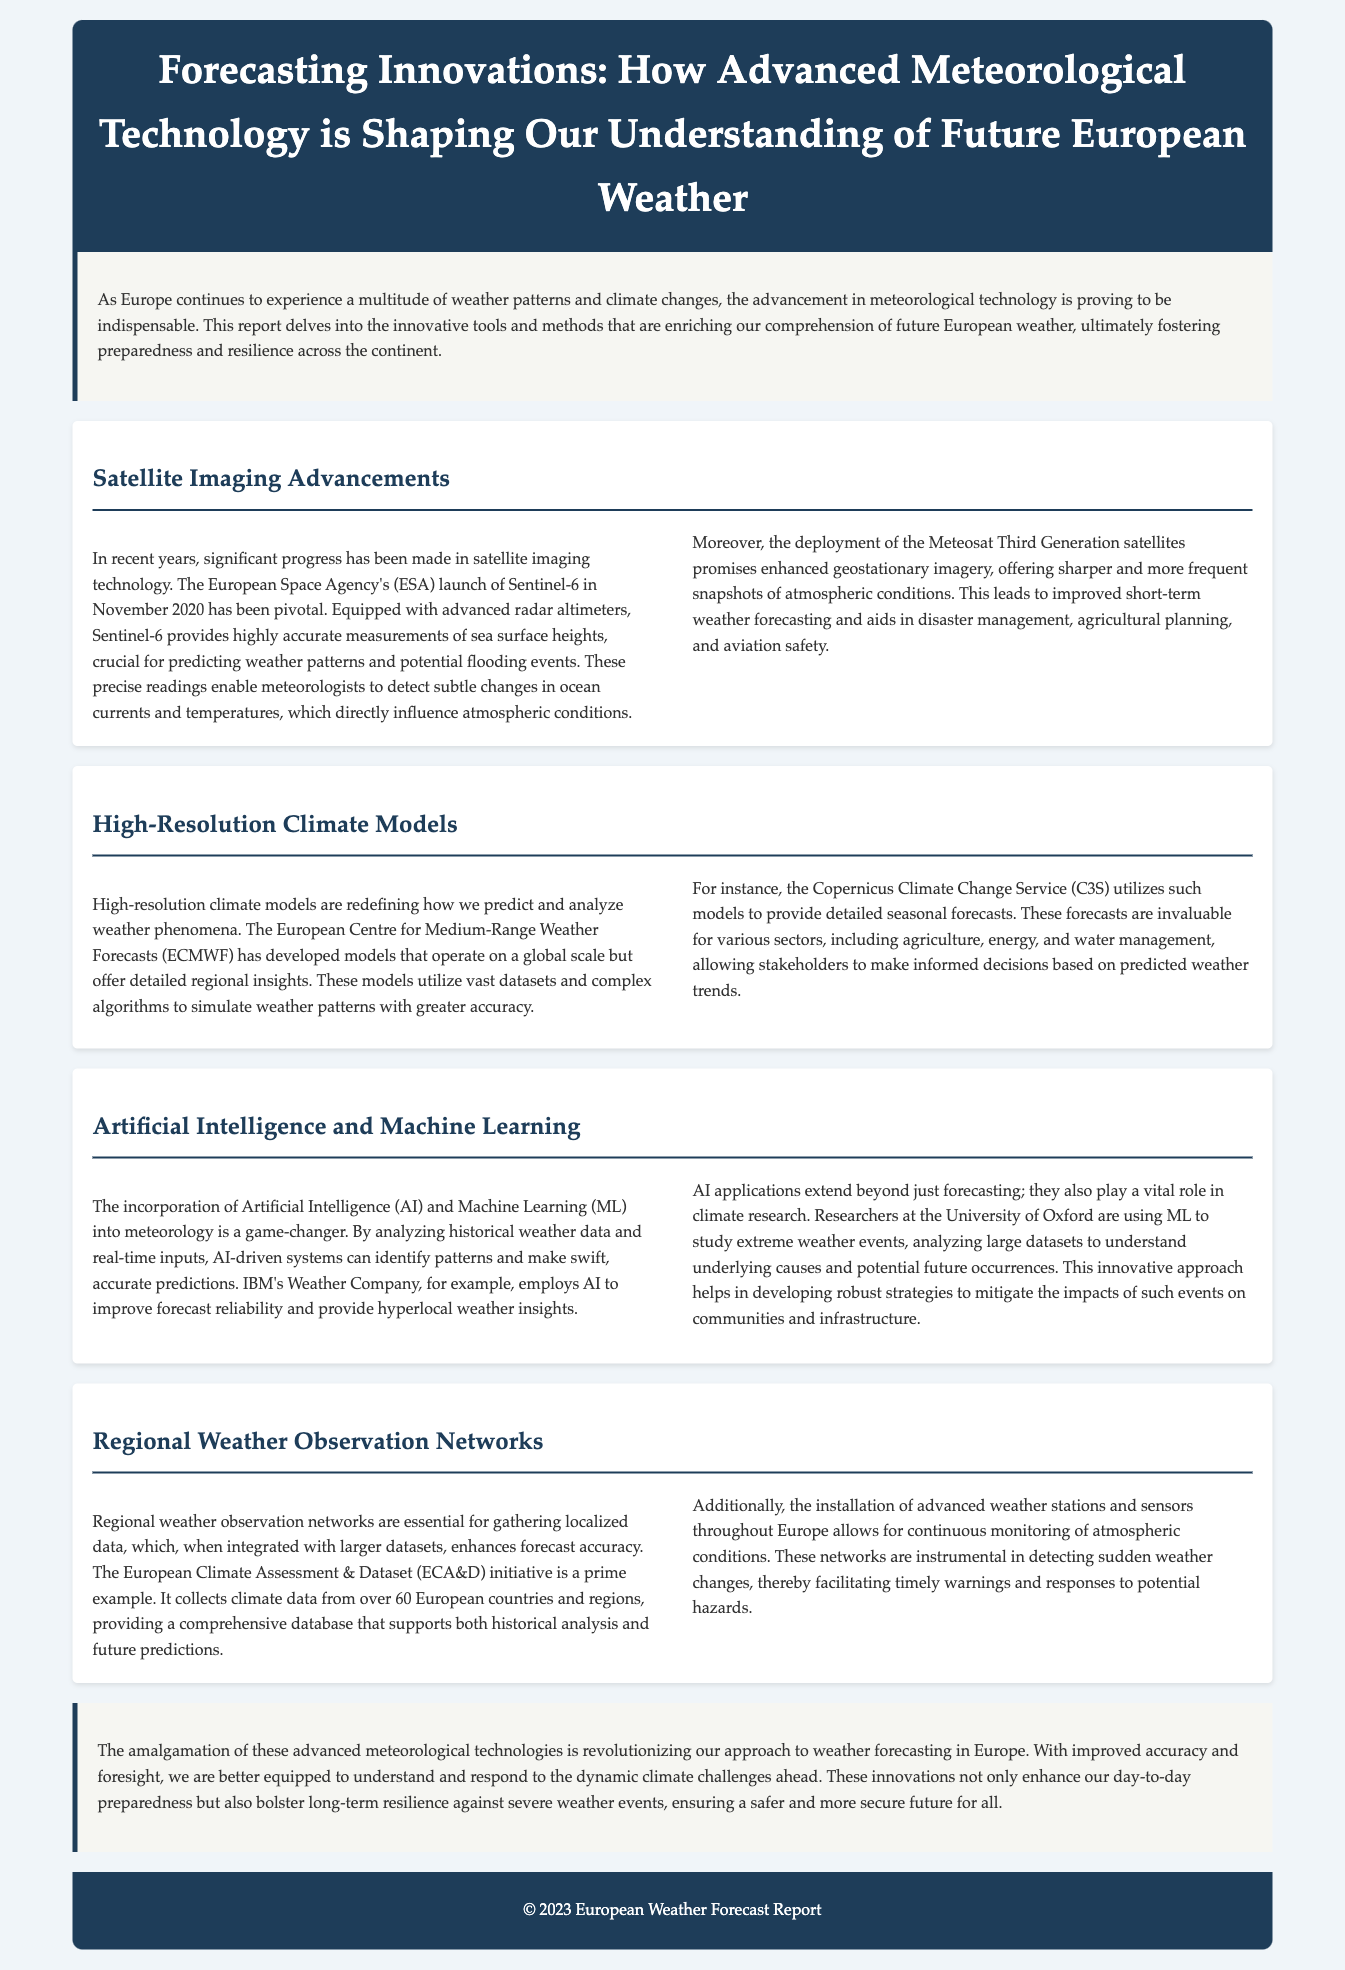What significant satellite was launched by the European Space Agency in November 2020? The document mentions the launch of Sentinel-6 by the European Space Agency in November 2020, which is significant for weather prediction.
Answer: Sentinel-6 What is the primary function of the advanced radar altimeters on Sentinel-6? The advanced radar altimeters on Sentinel-6 are designed to provide highly accurate measurements of sea surface heights, crucial for predicting weather patterns.
Answer: Predicting weather patterns Which organization developed high-resolution climate models that provide valuable regional insights? The European Centre for Medium-Range Weather Forecasts (ECMWF) is the organization credited with developing high-resolution climate models that offer detailed regional insights.
Answer: ECMWF What technology is being used by IBM's Weather Company to improve forecast reliability? IBM's Weather Company employs Artificial Intelligence (AI) to enhance the reliability of weather forecasts.
Answer: Artificial Intelligence How many European countries does the European Climate Assessment & Dataset initiative collect climate data from? The document states that the European Climate Assessment & Dataset initiative collects climate data from over 60 European countries and regions.
Answer: Over 60 What innovative approach are researchers at the University of Oxford using to study extreme weather events? Researchers at the University of Oxford are utilizing Machine Learning (ML) to analyze large datasets related to extreme weather events.
Answer: Machine Learning What major advantage do high-resolution climate models provide for sectors like agriculture and energy? High-resolution climate models allow stakeholders in agriculture, energy, and water management to make informed decisions based on predicted weather trends.
Answer: Informed decisions What is one consequence of the advancements in meteorological technology mentioned in the conclusion? The advancements in meteorological technology enhance preparedness and bolster long-term resilience against severe weather events.
Answer: Enhance preparedness What is the primary benefit of integrating localized data from regional weather observation networks? Integrating localized data enhances overall forecast accuracy, especially when combined with larger datasets.
Answer: Enhances forecast accuracy 